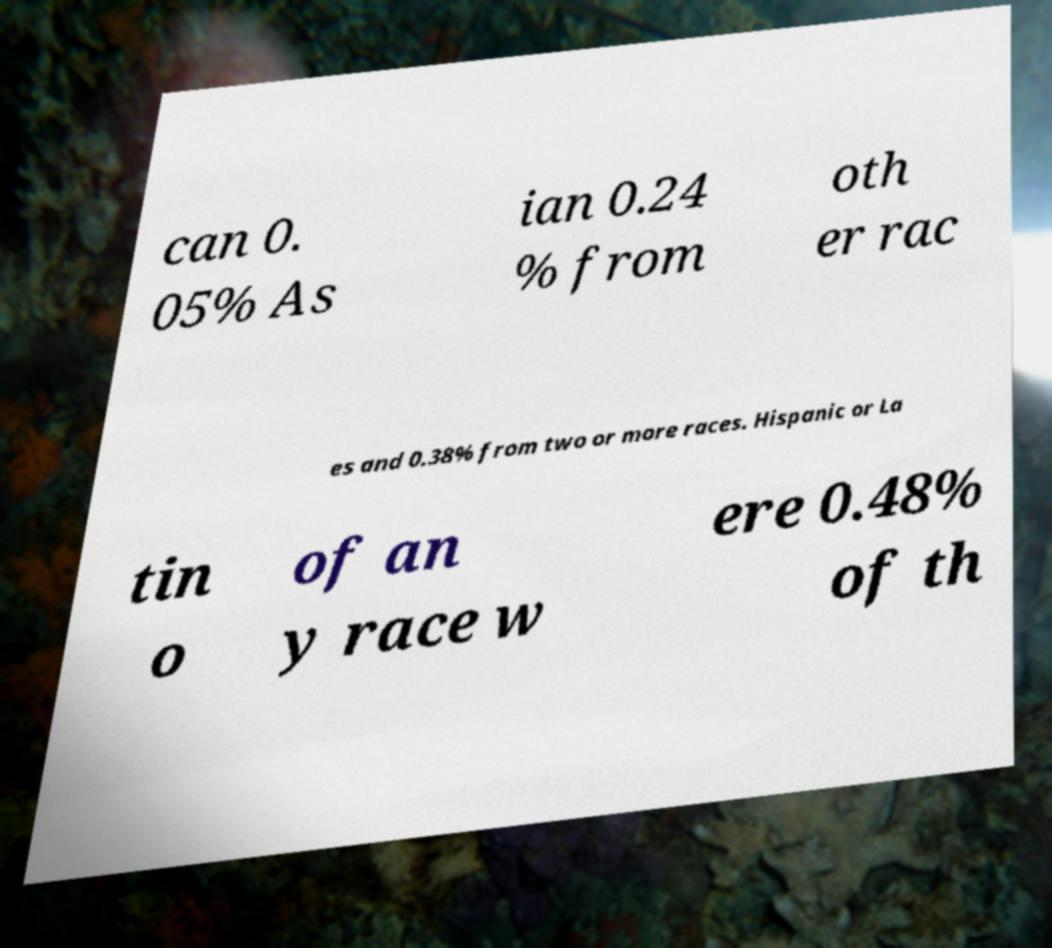Please identify and transcribe the text found in this image. can 0. 05% As ian 0.24 % from oth er rac es and 0.38% from two or more races. Hispanic or La tin o of an y race w ere 0.48% of th 